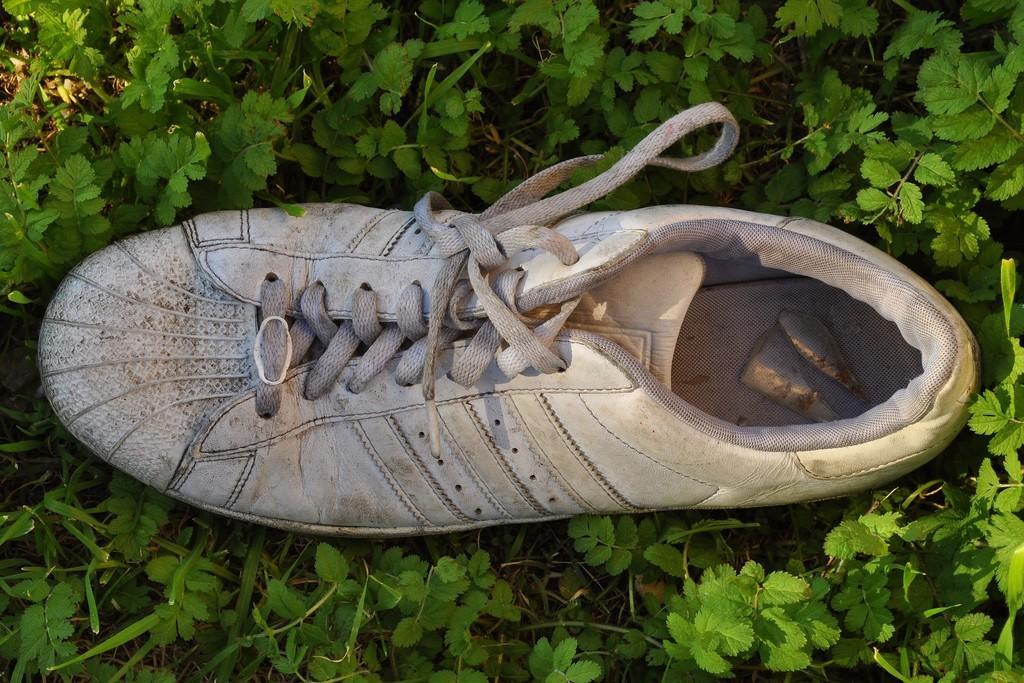How would you summarize this image in a sentence or two? In this image I can see the white color shoe and few green color plants around. 